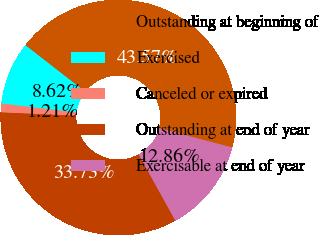Convert chart. <chart><loc_0><loc_0><loc_500><loc_500><pie_chart><fcel>Outstanding at beginning of<fcel>Exercised<fcel>Canceled or expired<fcel>Outstanding at end of year<fcel>Exercisable at end of year<nl><fcel>43.57%<fcel>8.62%<fcel>1.21%<fcel>33.73%<fcel>12.86%<nl></chart> 